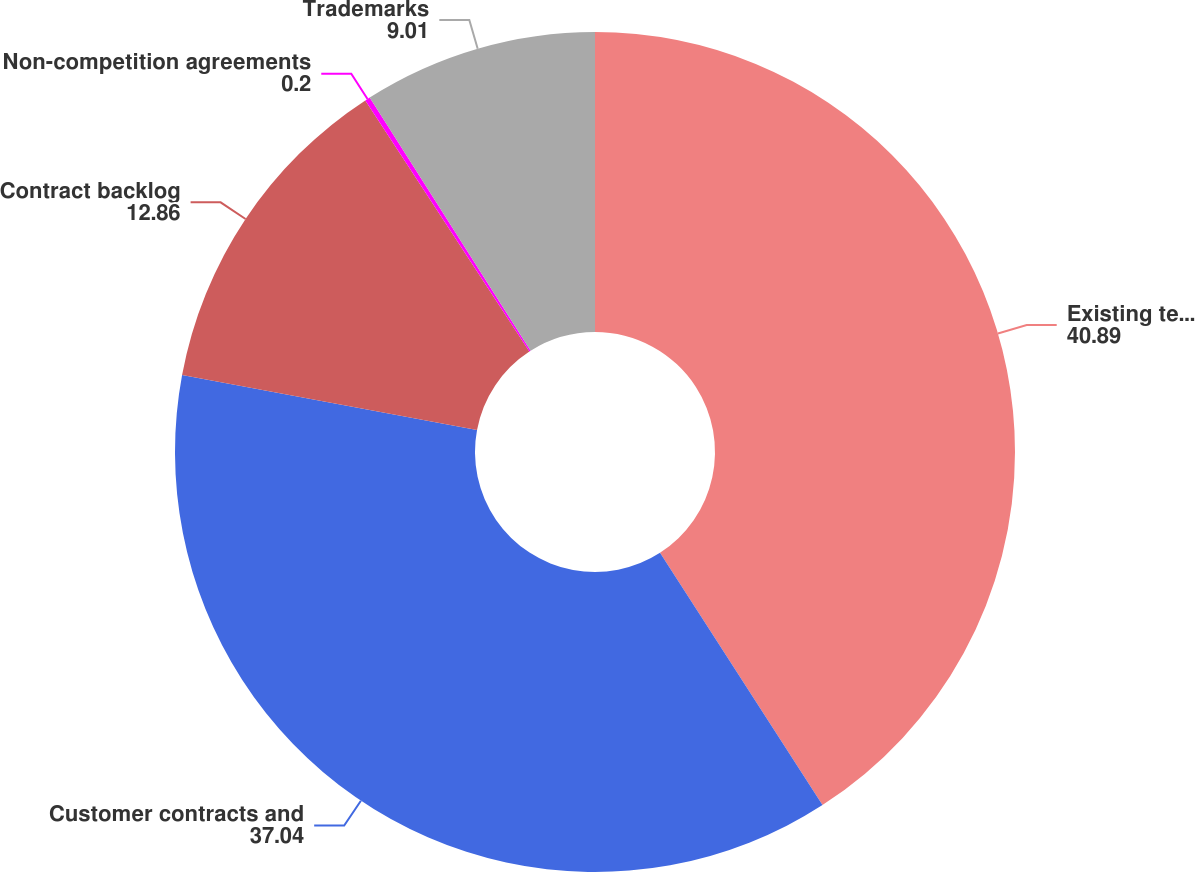Convert chart. <chart><loc_0><loc_0><loc_500><loc_500><pie_chart><fcel>Existing technology<fcel>Customer contracts and<fcel>Contract backlog<fcel>Non-competition agreements<fcel>Trademarks<nl><fcel>40.89%<fcel>37.04%<fcel>12.86%<fcel>0.2%<fcel>9.01%<nl></chart> 